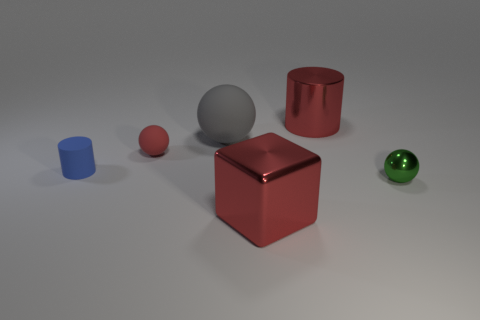Subtract all rubber spheres. How many spheres are left? 1 Subtract 1 balls. How many balls are left? 2 Add 2 tiny red spheres. How many objects exist? 8 Subtract all blue spheres. Subtract all yellow cylinders. How many spheres are left? 3 Subtract all cylinders. How many objects are left? 4 Subtract all tiny green objects. Subtract all tiny blue cylinders. How many objects are left? 4 Add 4 blue matte cylinders. How many blue matte cylinders are left? 5 Add 3 tiny purple blocks. How many tiny purple blocks exist? 3 Subtract 0 purple balls. How many objects are left? 6 